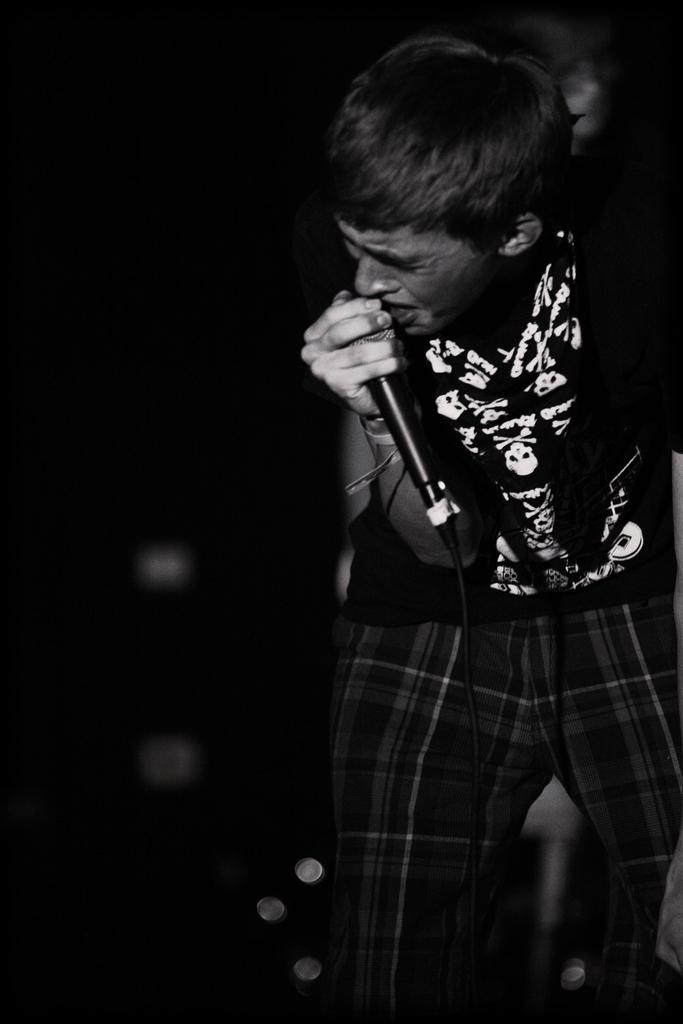What is the main subject of the image? There is a person in the image. What is the person holding in his hand? The person is holding a mic in his hand. What color scheme is used in the image? The image is in black and white color. What type of juice is the person drinking in the image? There is no juice present in the image; the person is holding a mic. How does the person's stomach feel in the image? There is no information about the person's stomach or feelings in the image. 